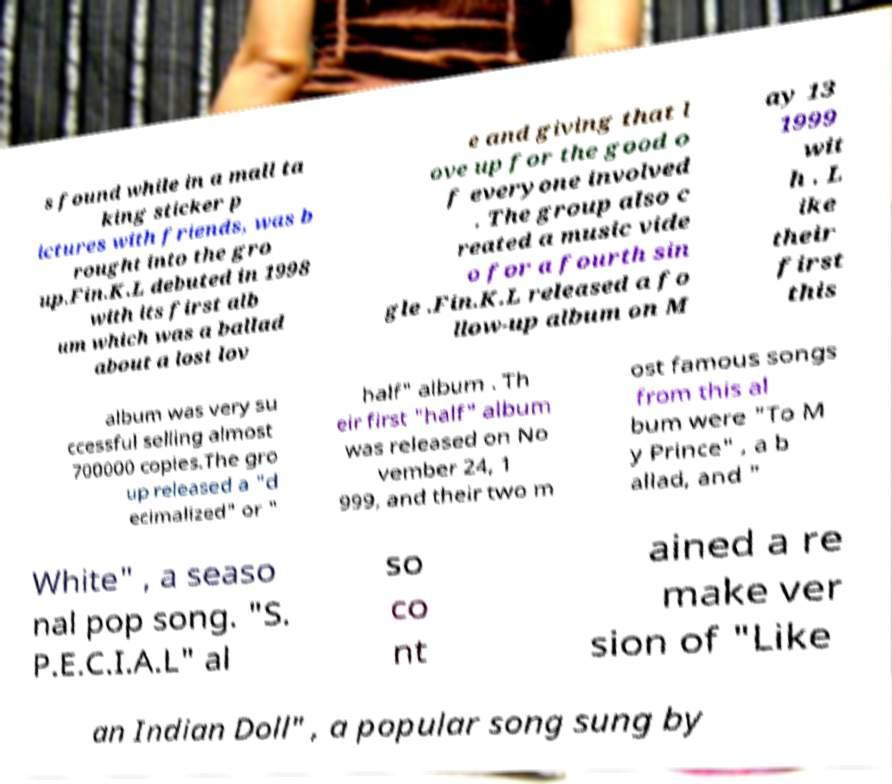I need the written content from this picture converted into text. Can you do that? s found while in a mall ta king sticker p ictures with friends, was b rought into the gro up.Fin.K.L debuted in 1998 with its first alb um which was a ballad about a lost lov e and giving that l ove up for the good o f everyone involved . The group also c reated a music vide o for a fourth sin gle .Fin.K.L released a fo llow-up album on M ay 13 1999 wit h . L ike their first this album was very su ccessful selling almost 700000 copies.The gro up released a "d ecimalized" or " half" album . Th eir first "half" album was released on No vember 24, 1 999, and their two m ost famous songs from this al bum were "To M y Prince" , a b allad, and " White" , a seaso nal pop song. "S. P.E.C.I.A.L" al so co nt ained a re make ver sion of "Like an Indian Doll" , a popular song sung by 